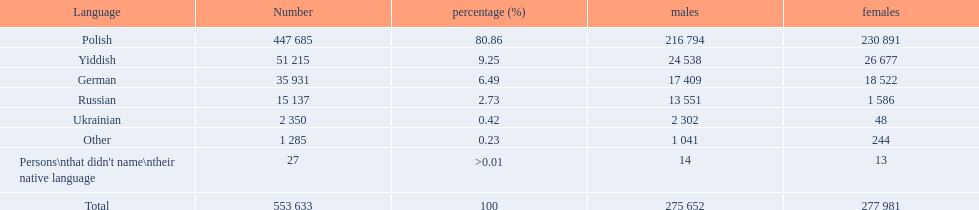What are all of the linguistic systems? Polish, Yiddish, German, Russian, Ukrainian, Other, Persons\nthat didn't name\ntheir native language. And how many people use these linguistic systems? 447 685, 51 215, 35 931, 15 137, 2 350, 1 285, 27. Which linguistic system is adopted by the largest number of people? Polish. 